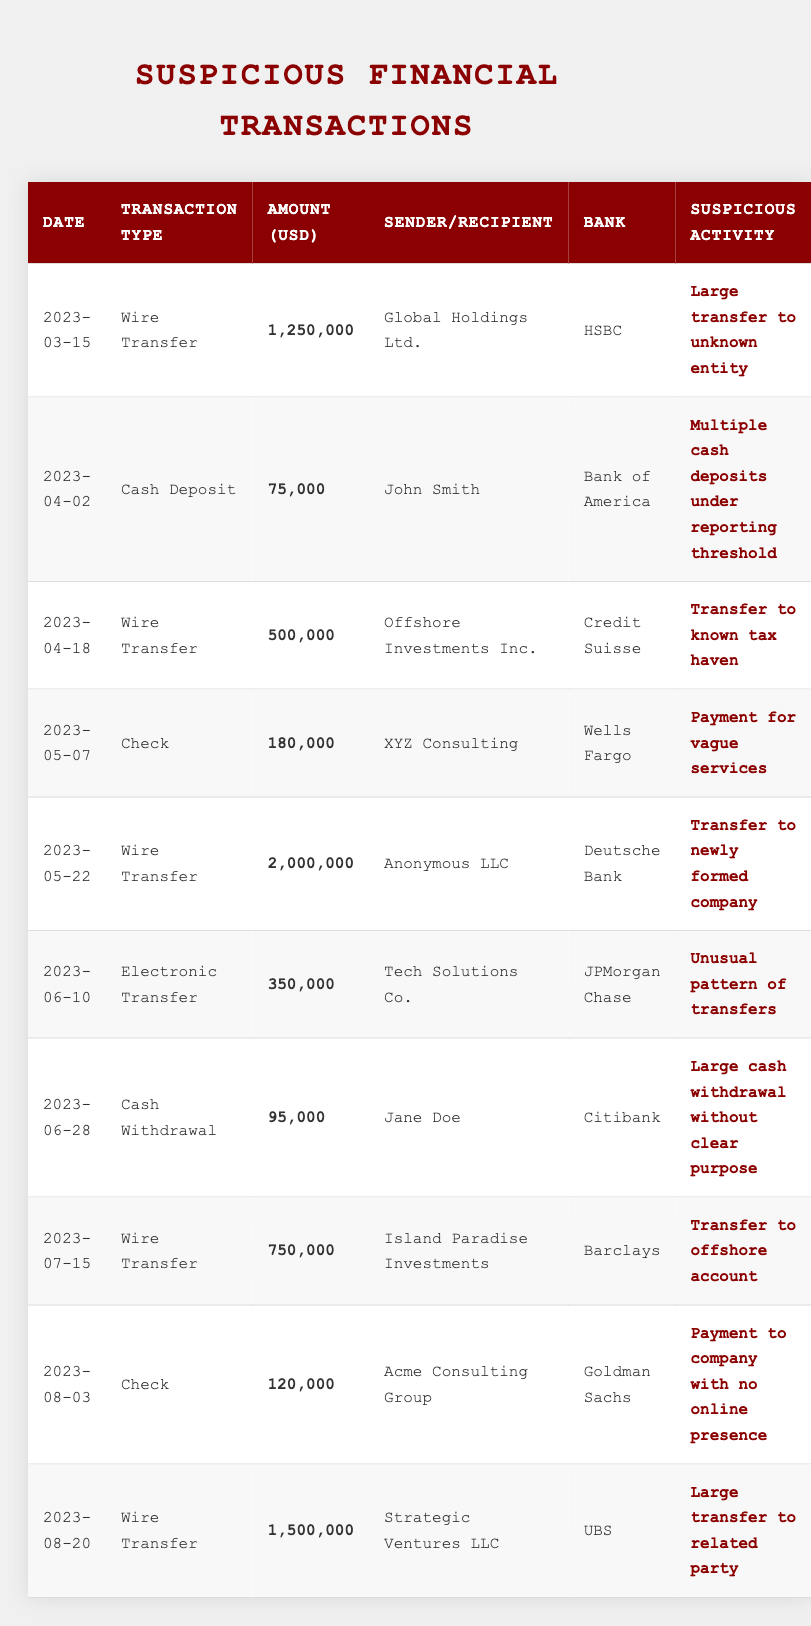What is the largest transaction recorded in this table? The largest transaction amount in the table is 2,000,000, which is a wire transfer from Anonymous LLC at Deutsche Bank on May 22, 2023.
Answer: 2,000,000 How many wire transfers are recorded in the table? There are six transactions marked as wire transfers across the entries with respective dates listed. This can be counted by filtering the transaction type only for wire transfers.
Answer: 6 Is there a transaction that involved cash withdrawal? Yes, there is one cash withdrawal transaction recorded on June 28, 2023, with Jane Doe as the recipient for an amount of 95,000 at Citibank.
Answer: Yes What is the total amount of all cash deposits recorded? The only cash deposit recorded is 75,000 from John Smith at Bank of America on April 2, 2023. Since there are no other cash deposits, the total amount is 75,000.
Answer: 75,000 Which bank processed the most transactions in this table? By examining the bank column and counting transactions, HSBC and Deutsche Bank each have one transaction. Other banks like Bank of America, Credit Suisse, Wells Fargo, JPMorgan Chase, Barclays, Goldman Sachs, and UBS have one transaction, totaling eight unique banks, each representing one transaction. No bank processed more than one transaction.
Answer: None What type of transaction did Island Paradise Investments conduct, and what was its amount? Island Paradise Investments conducted a wire transfer for an amount of 750,000 on July 15, 2023. This can be identified by looking at the row corresponding to the company.
Answer: Wire Transfer, 750,000 Is the payment for services to XYZ Consulting considered suspicious activity? Yes, the payment of 180,000 to XYZ Consulting for vague services is flagged as suspicious activity. This can be confirmed by referring to the 'Suspicious Activity' column detailing each transaction.
Answer: Yes What is the difference between the largest and smallest wire transfer amounts recorded? The largest wire transfer is 2,000,000 (Anonymous LLC) and the smallest is 500,000 (Offshore Investments Inc.). Therefore, the difference is calculated as 2,000,000 - 500,000 = 1,500,000.
Answer: 1,500,000 How many checks are recorded in the table? There are two checks recorded in the table. This can be found by counting the rows with the transaction type listed as 'Check'.
Answer: 2 